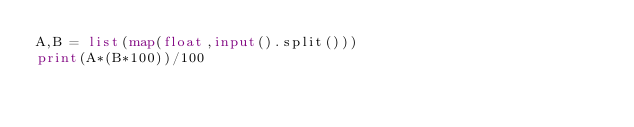Convert code to text. <code><loc_0><loc_0><loc_500><loc_500><_Python_>A,B = list(map(float,input().split()))
print(A*(B*100))/100</code> 